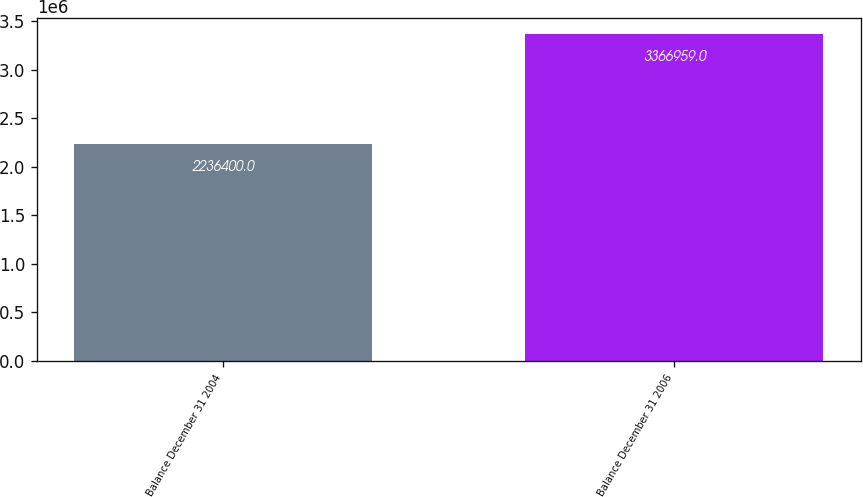Convert chart. <chart><loc_0><loc_0><loc_500><loc_500><bar_chart><fcel>Balance December 31 2004<fcel>Balance December 31 2006<nl><fcel>2.2364e+06<fcel>3.36696e+06<nl></chart> 